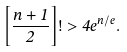<formula> <loc_0><loc_0><loc_500><loc_500>\left [ \frac { n + 1 } { 2 } \right ] ! > 4 e ^ { n / e } .</formula> 